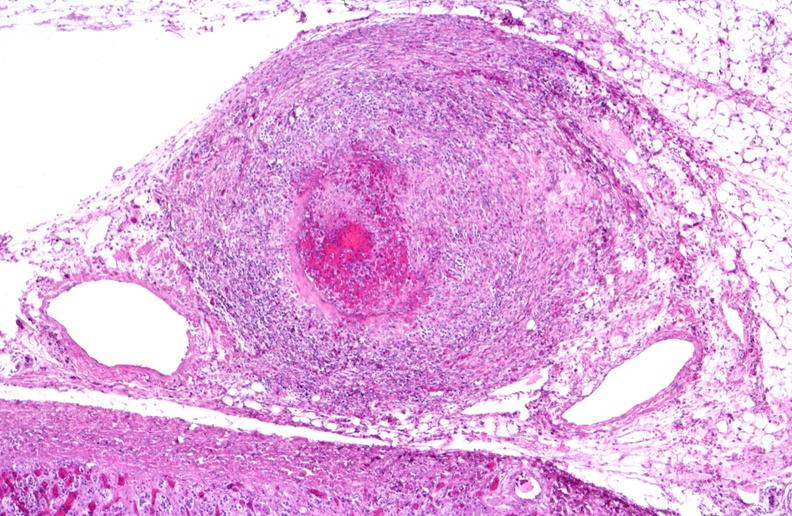s cardiovascular present?
Answer the question using a single word or phrase. Yes 